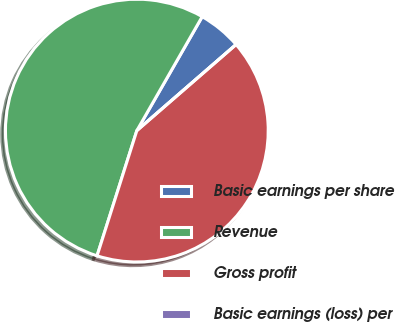<chart> <loc_0><loc_0><loc_500><loc_500><pie_chart><fcel>Basic earnings per share<fcel>Revenue<fcel>Gross profit<fcel>Basic earnings (loss) per<nl><fcel>5.34%<fcel>53.39%<fcel>41.27%<fcel>0.0%<nl></chart> 